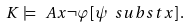<formula> <loc_0><loc_0><loc_500><loc_500>K \models \ A { x } \neg \varphi [ \psi \ s u b s t x ] \, .</formula> 